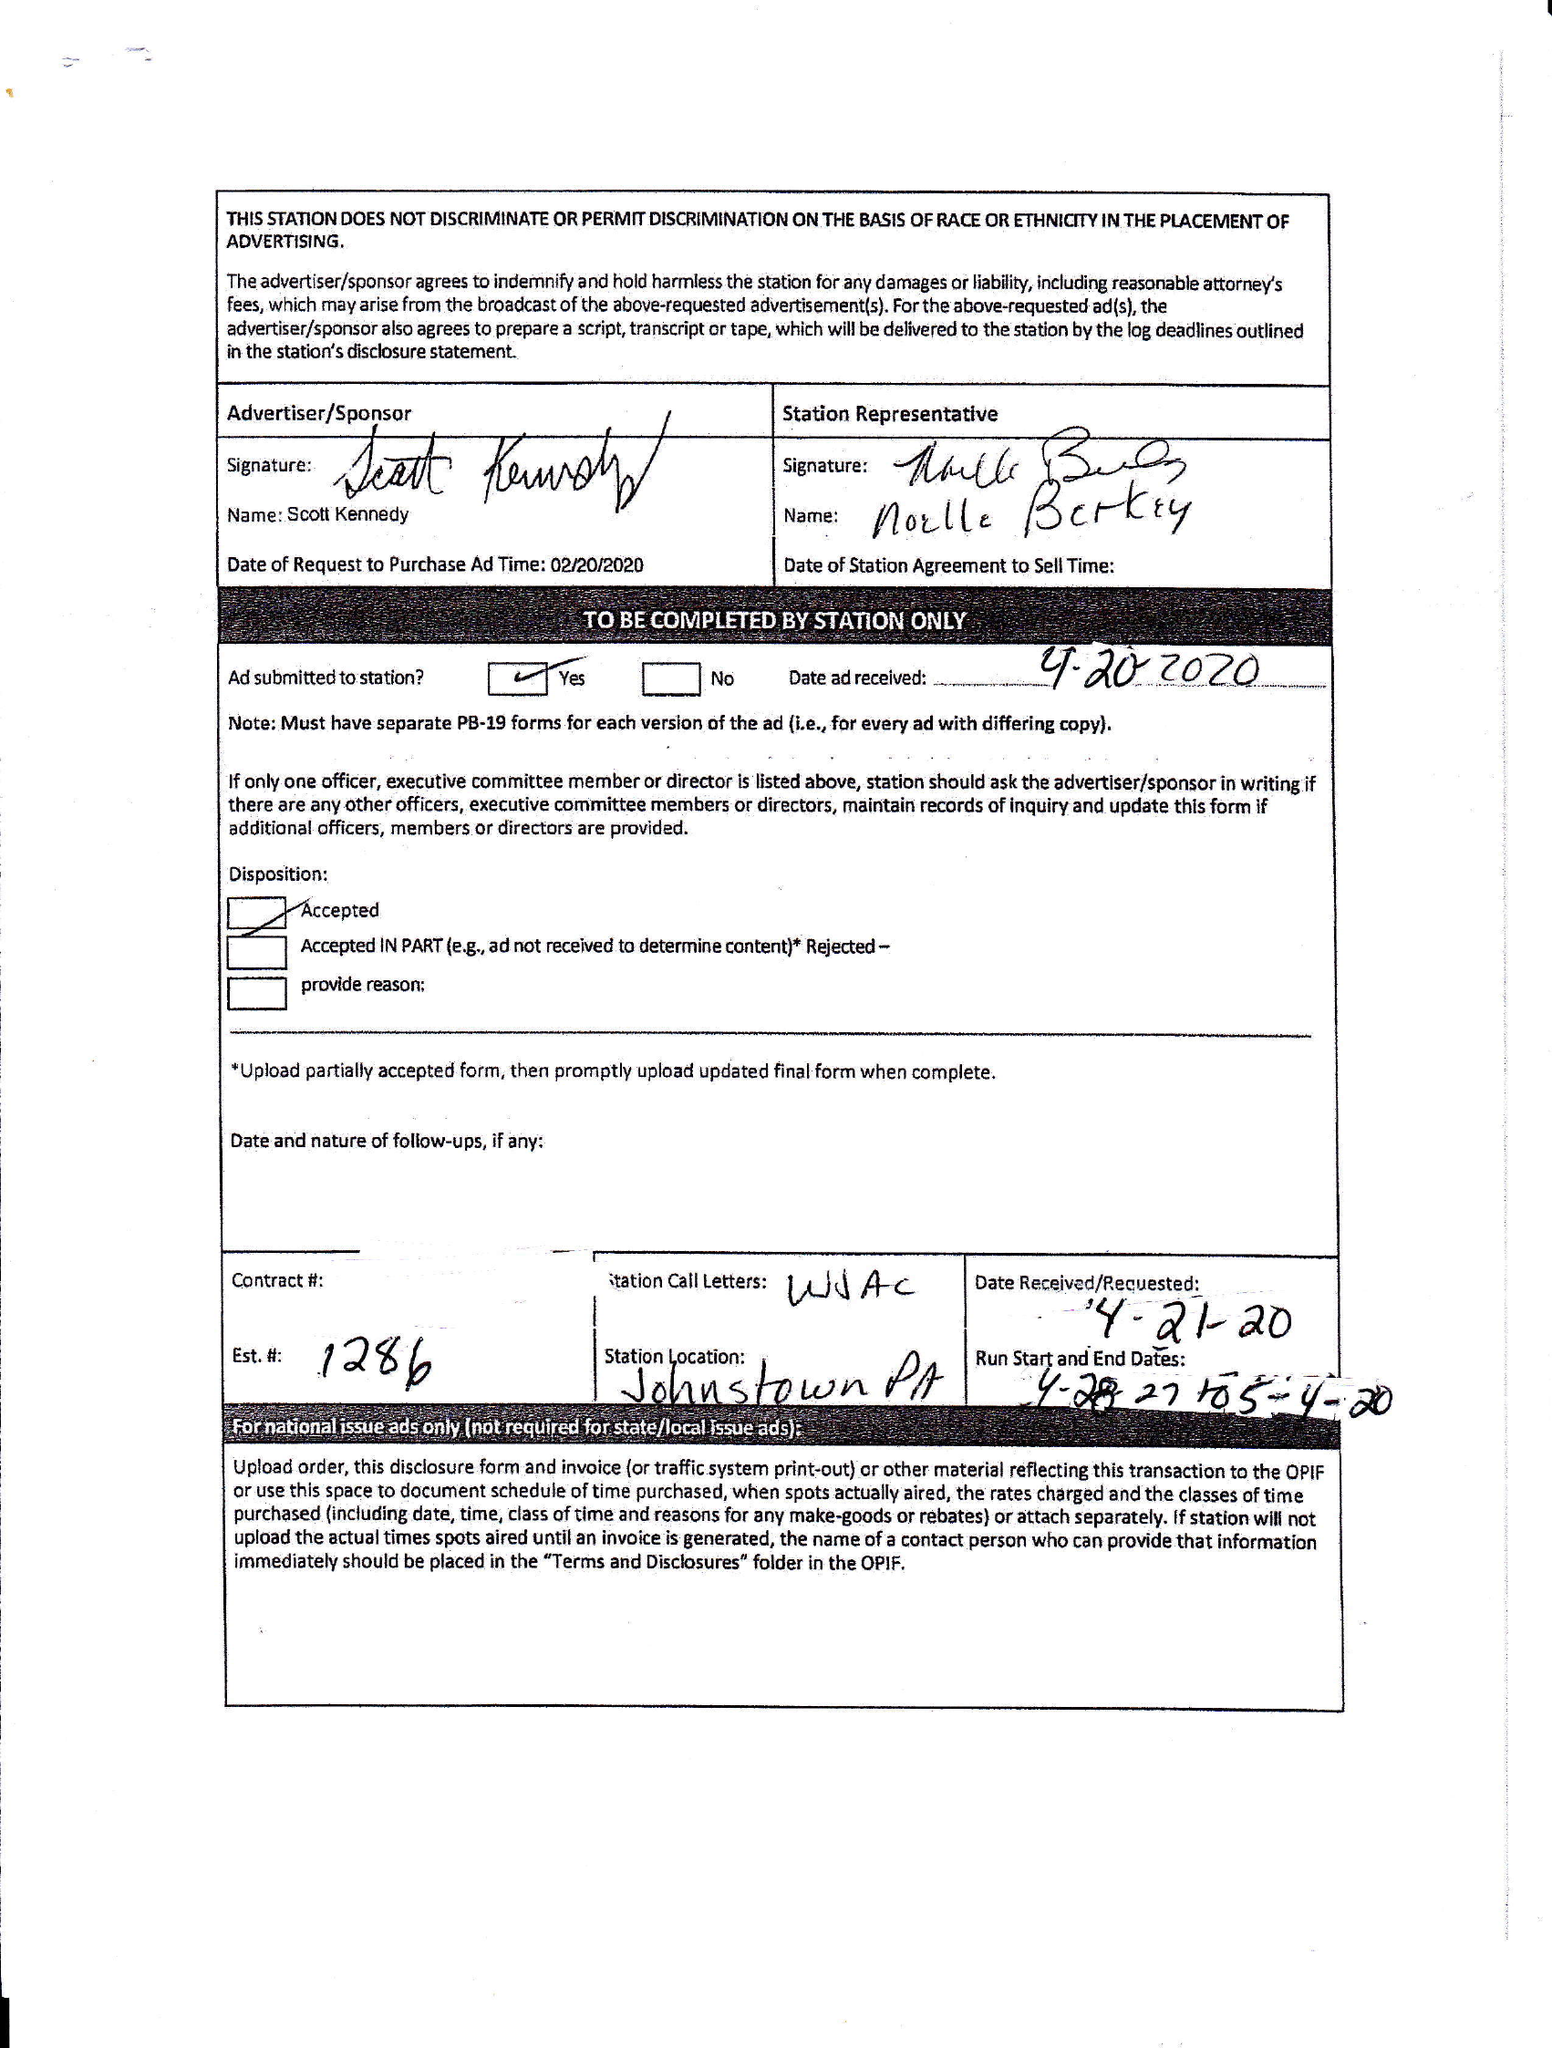What is the value for the gross_amount?
Answer the question using a single word or phrase. None 